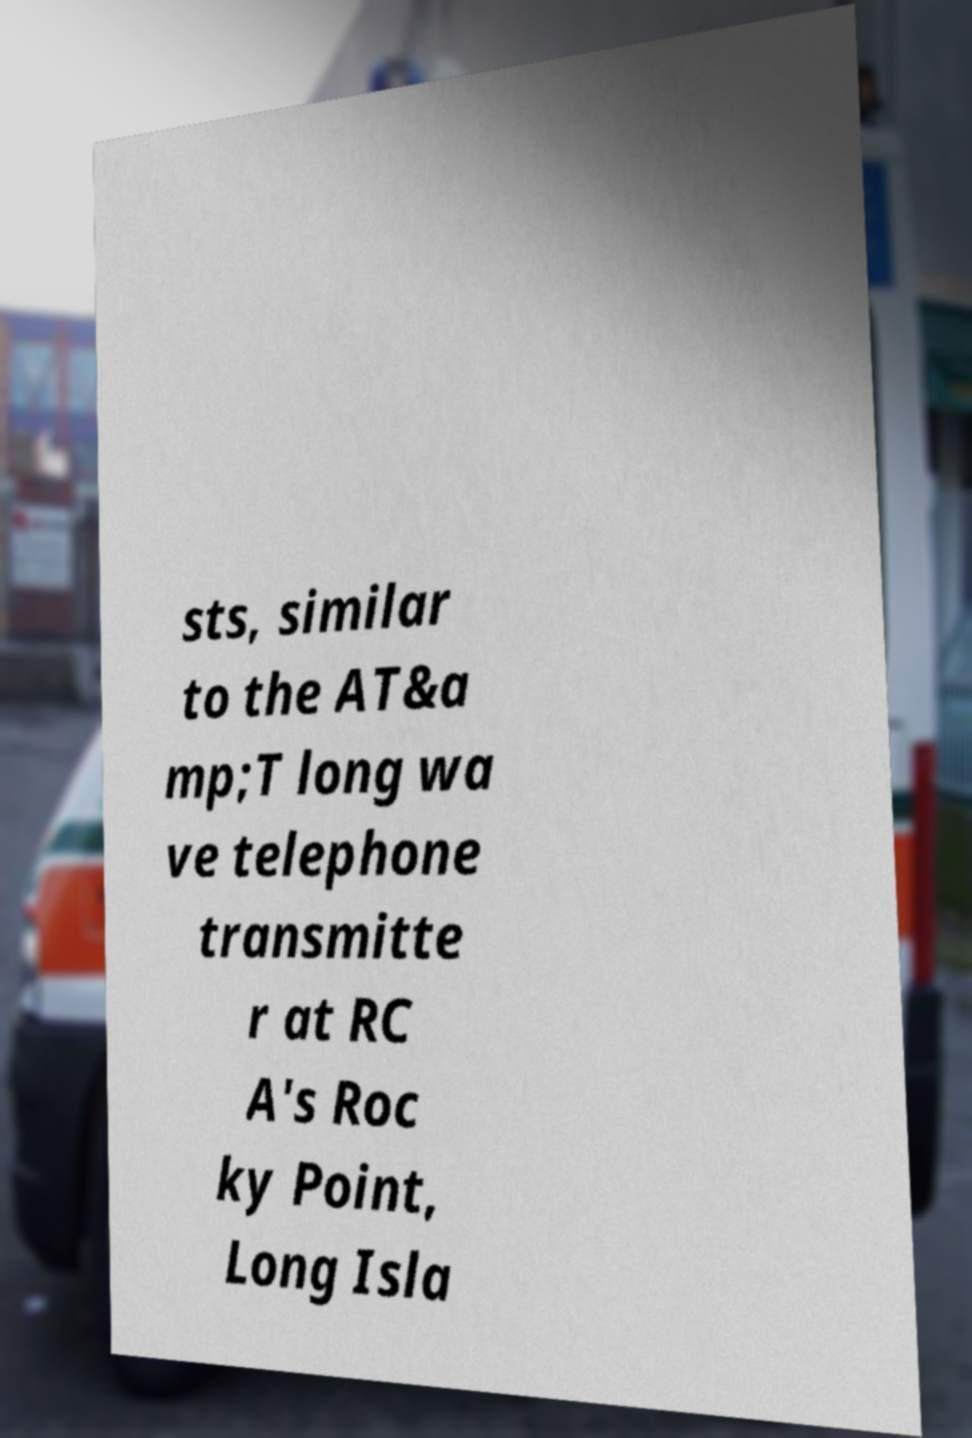Please identify and transcribe the text found in this image. sts, similar to the AT&a mp;T long wa ve telephone transmitte r at RC A's Roc ky Point, Long Isla 